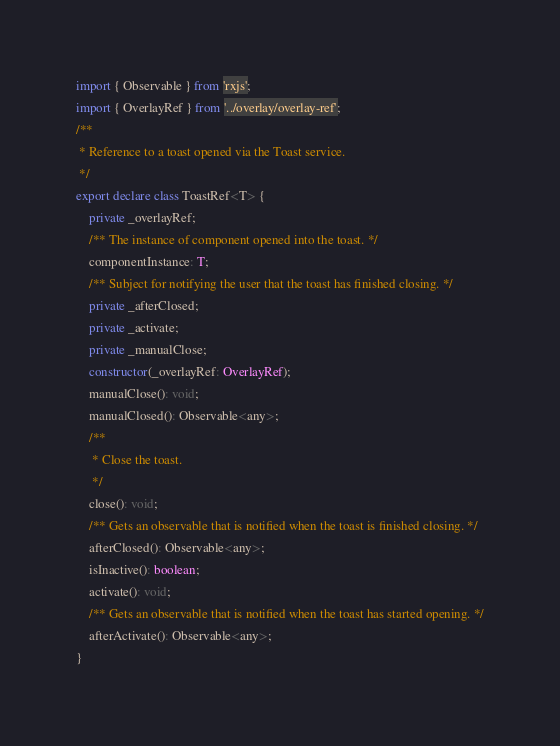<code> <loc_0><loc_0><loc_500><loc_500><_TypeScript_>import { Observable } from 'rxjs';
import { OverlayRef } from '../overlay/overlay-ref';
/**
 * Reference to a toast opened via the Toast service.
 */
export declare class ToastRef<T> {
    private _overlayRef;
    /** The instance of component opened into the toast. */
    componentInstance: T;
    /** Subject for notifying the user that the toast has finished closing. */
    private _afterClosed;
    private _activate;
    private _manualClose;
    constructor(_overlayRef: OverlayRef);
    manualClose(): void;
    manualClosed(): Observable<any>;
    /**
     * Close the toast.
     */
    close(): void;
    /** Gets an observable that is notified when the toast is finished closing. */
    afterClosed(): Observable<any>;
    isInactive(): boolean;
    activate(): void;
    /** Gets an observable that is notified when the toast has started opening. */
    afterActivate(): Observable<any>;
}
</code> 